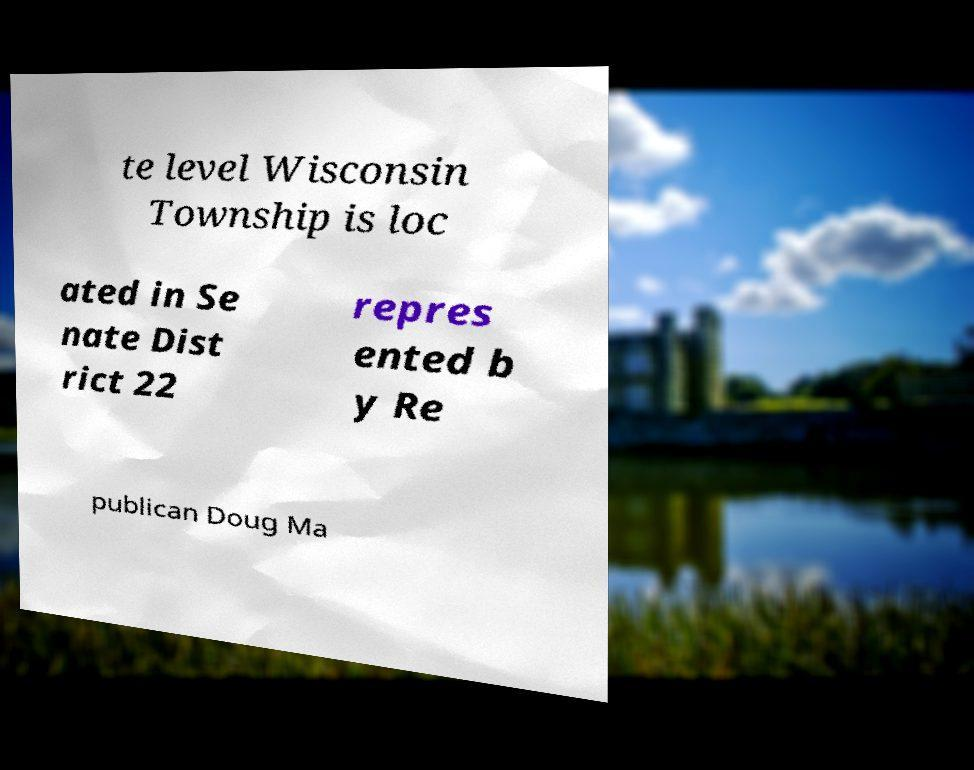Can you read and provide the text displayed in the image?This photo seems to have some interesting text. Can you extract and type it out for me? te level Wisconsin Township is loc ated in Se nate Dist rict 22 repres ented b y Re publican Doug Ma 